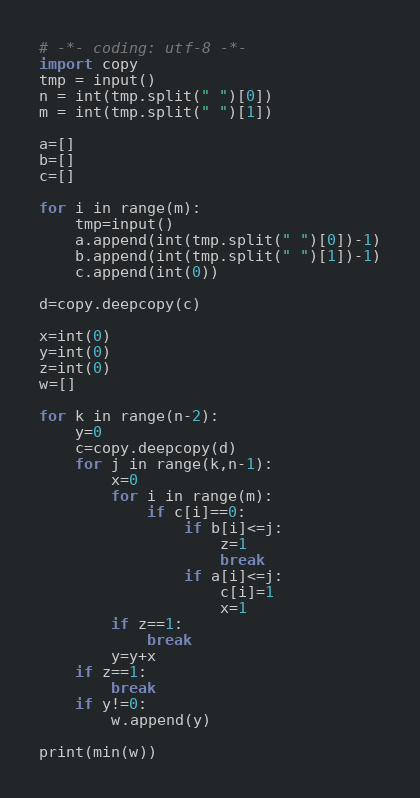Convert code to text. <code><loc_0><loc_0><loc_500><loc_500><_Python_># -*- coding: utf-8 -*-
import copy
tmp = input()
n = int(tmp.split(" ")[0])
m = int(tmp.split(" ")[1])

a=[]
b=[]
c=[]

for i in range(m):
    tmp=input()
    a.append(int(tmp.split(" ")[0])-1)
    b.append(int(tmp.split(" ")[1])-1)
    c.append(int(0))

d=copy.deepcopy(c)

x=int(0)
y=int(0)
z=int(0)
w=[]

for k in range(n-2):
    y=0
    c=copy.deepcopy(d)
    for j in range(k,n-1):
        x=0
        for i in range(m):
            if c[i]==0:
                if b[i]<=j:
                    z=1
                    break
                if a[i]<=j:
                    c[i]=1
                    x=1
        if z==1:
            break
        y=y+x
    if z==1:
        break
    if y!=0:
        w.append(y)

print(min(w))</code> 